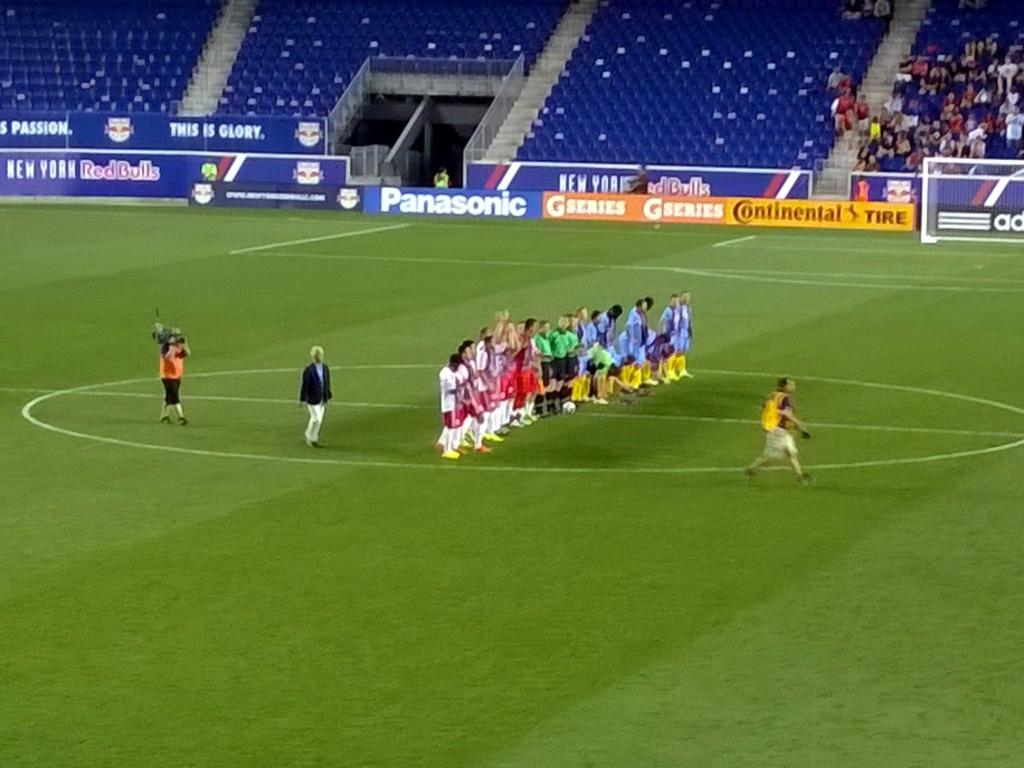<image>
Summarize the visual content of the image. Some people on a sports field which has an advert for Panasonic. 